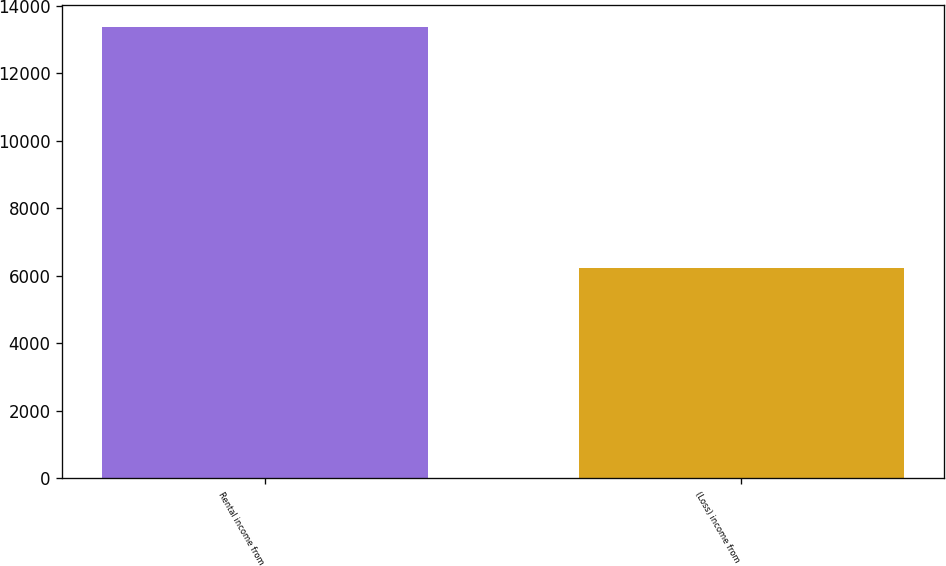<chart> <loc_0><loc_0><loc_500><loc_500><bar_chart><fcel>Rental income from<fcel>(Loss) income from<nl><fcel>13356<fcel>6239<nl></chart> 